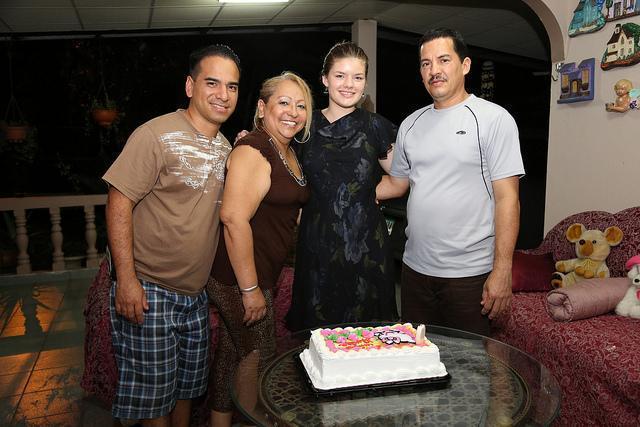Is the statement "The dining table is under the teddy bear." accurate regarding the image?
Answer yes or no. No. Evaluate: Does the caption "The dining table is touching the teddy bear." match the image?
Answer yes or no. No. 